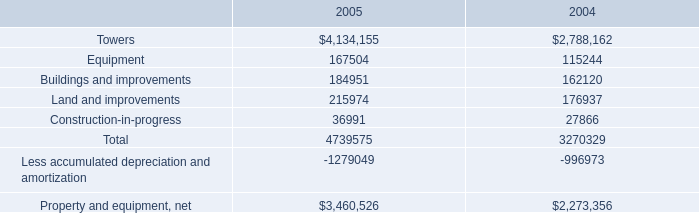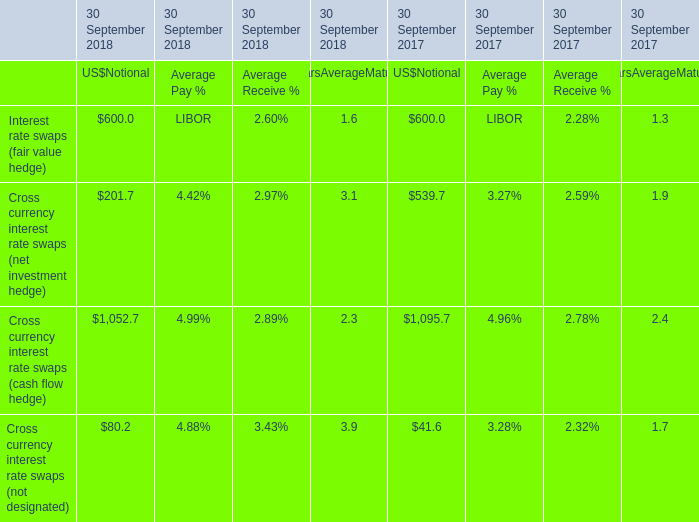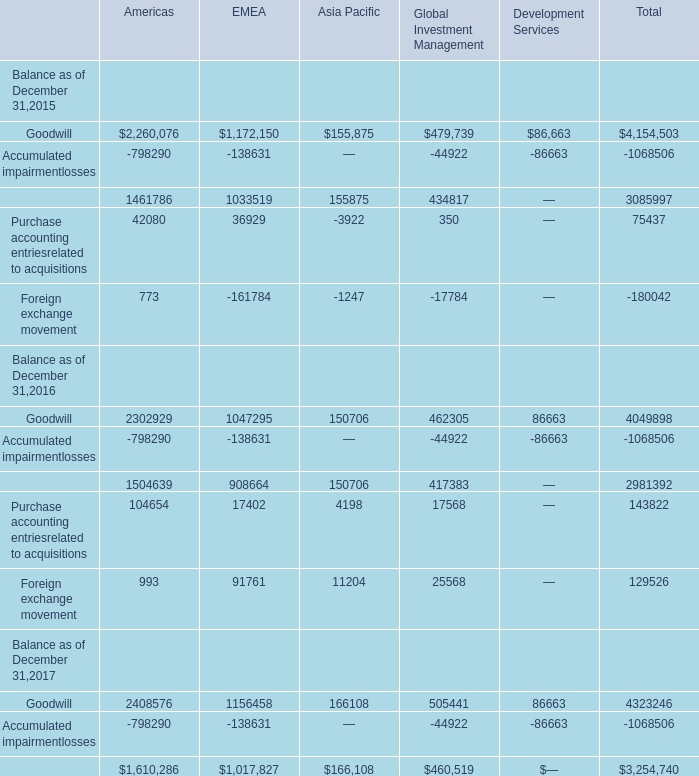What is the sum of Purchase accounting entriesrelated to acquisitions of Asia Pacific, and Property and equipment, net of 2004 ? 
Computations: (3922.0 + 2273356.0)
Answer: 2277278.0. 